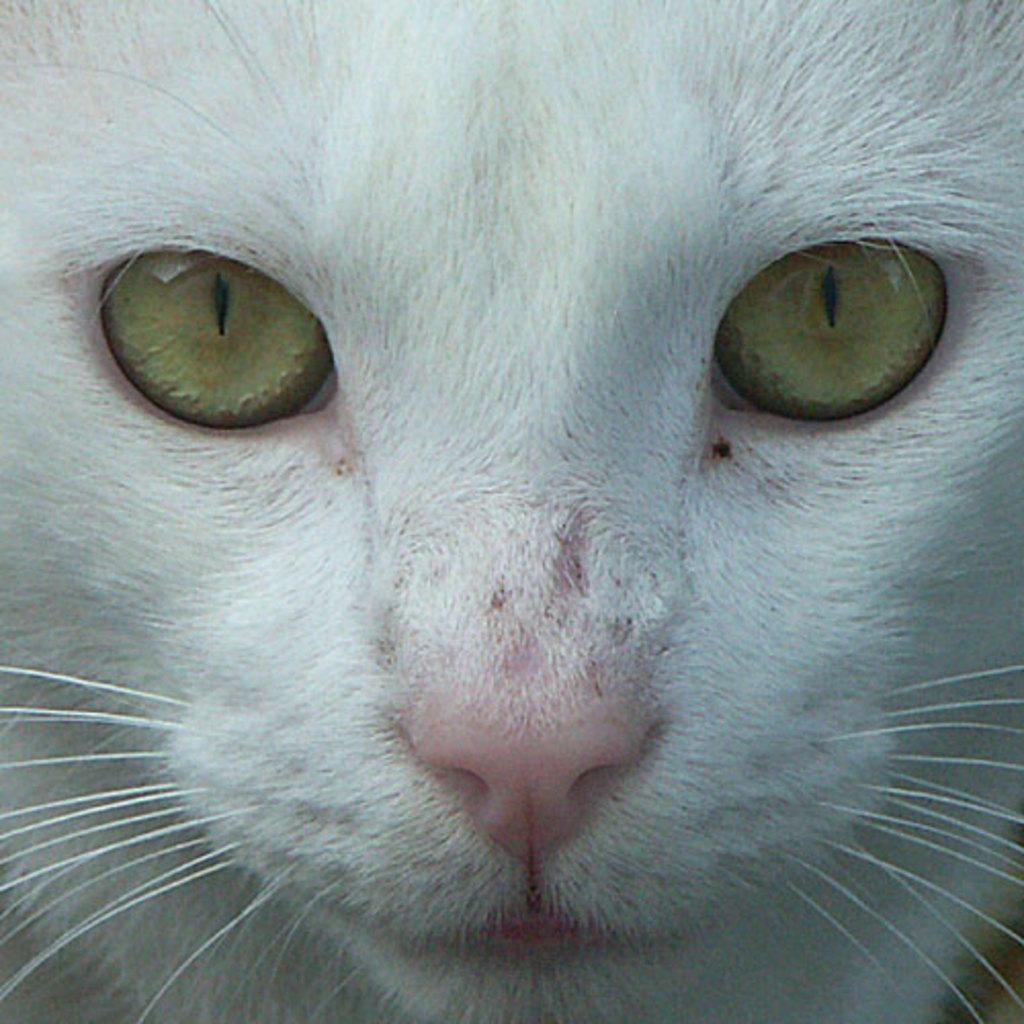What type of animal is in the image? There is a cat in the image. What color is the cat? The cat is white in color. How old is the cat's daughter in the image? There is no mention of a daughter or any other cat in the image, so we cannot determine the age of a cat's daughter. 